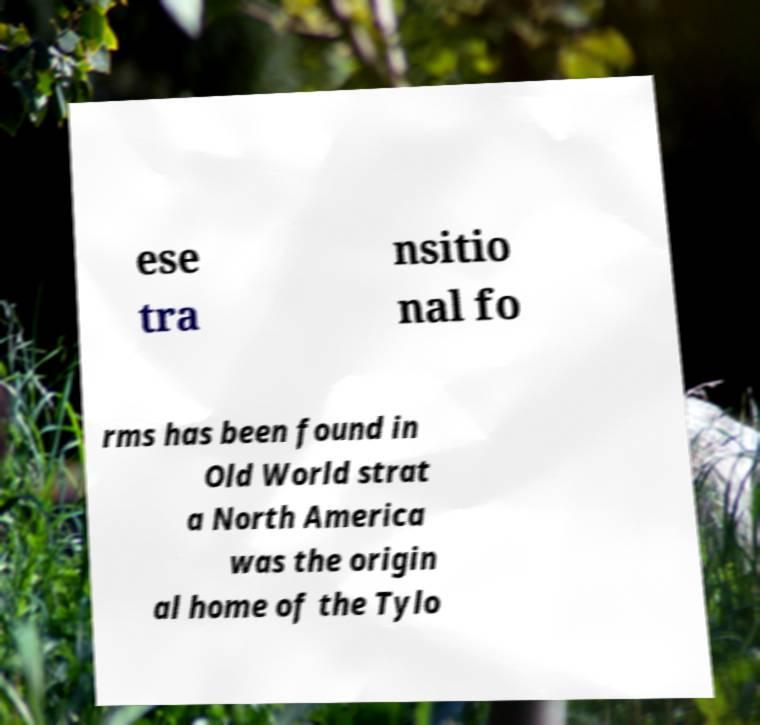Could you assist in decoding the text presented in this image and type it out clearly? ese tra nsitio nal fo rms has been found in Old World strat a North America was the origin al home of the Tylo 